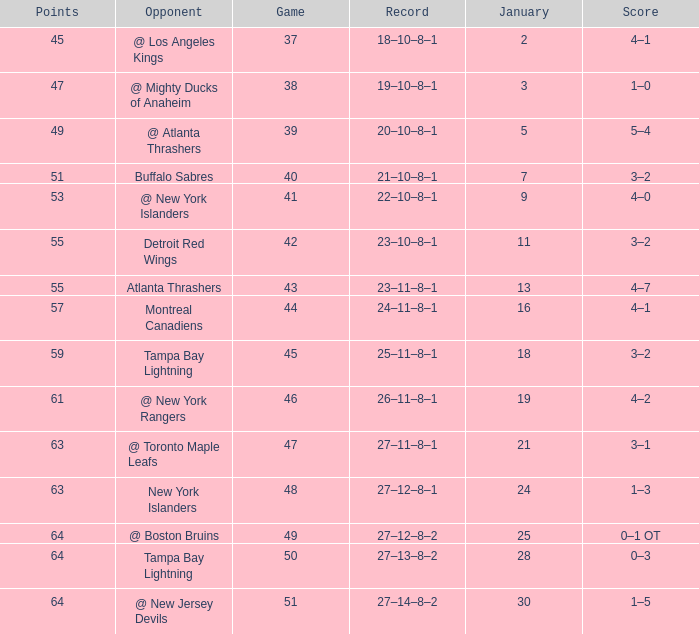Which Score has Points of 64, and a Game of 49? 0–1 OT. 